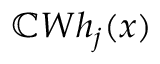<formula> <loc_0><loc_0><loc_500><loc_500>\mathbb { C } W h _ { j } ( x )</formula> 